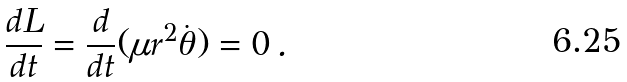Convert formula to latex. <formula><loc_0><loc_0><loc_500><loc_500>\frac { d L } { d t } = \frac { d } { d t } ( \mu r ^ { 2 } \dot { \theta } ) = 0 \, .</formula> 